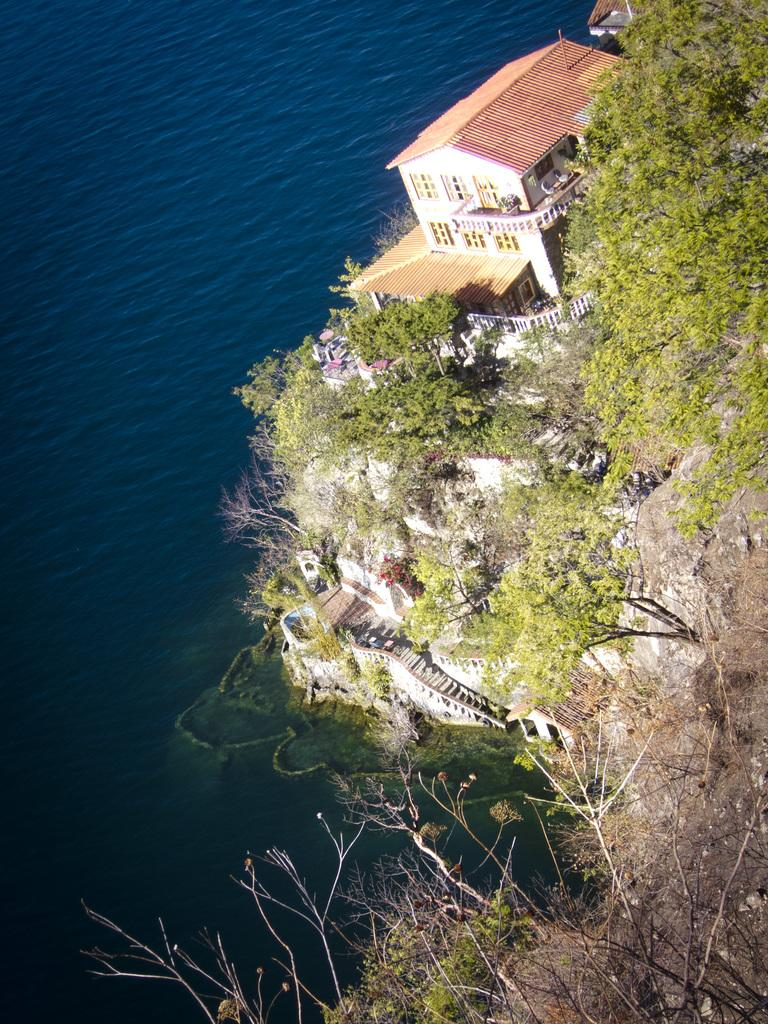What is the main structure visible in the foreground of the image? There is a house in the foreground of the image. Where is the house located in relation to the image? The house is on the right side of the image. What other objects or features can be seen in the foreground of the image? There are trees, a rock, and stairs on the right side of the image. What natural element is visible on the left side of the image? There is water on the left side of the image. What type of insurance policy is being discussed by the people near the water in the image? There are no people visible in the image, and no discussion about insurance policies is taking place. Can you tell me how many cups are stacked on the rock in the image? There are no cups present in the image; only a house, trees, a rock, stairs, and water are visible. 